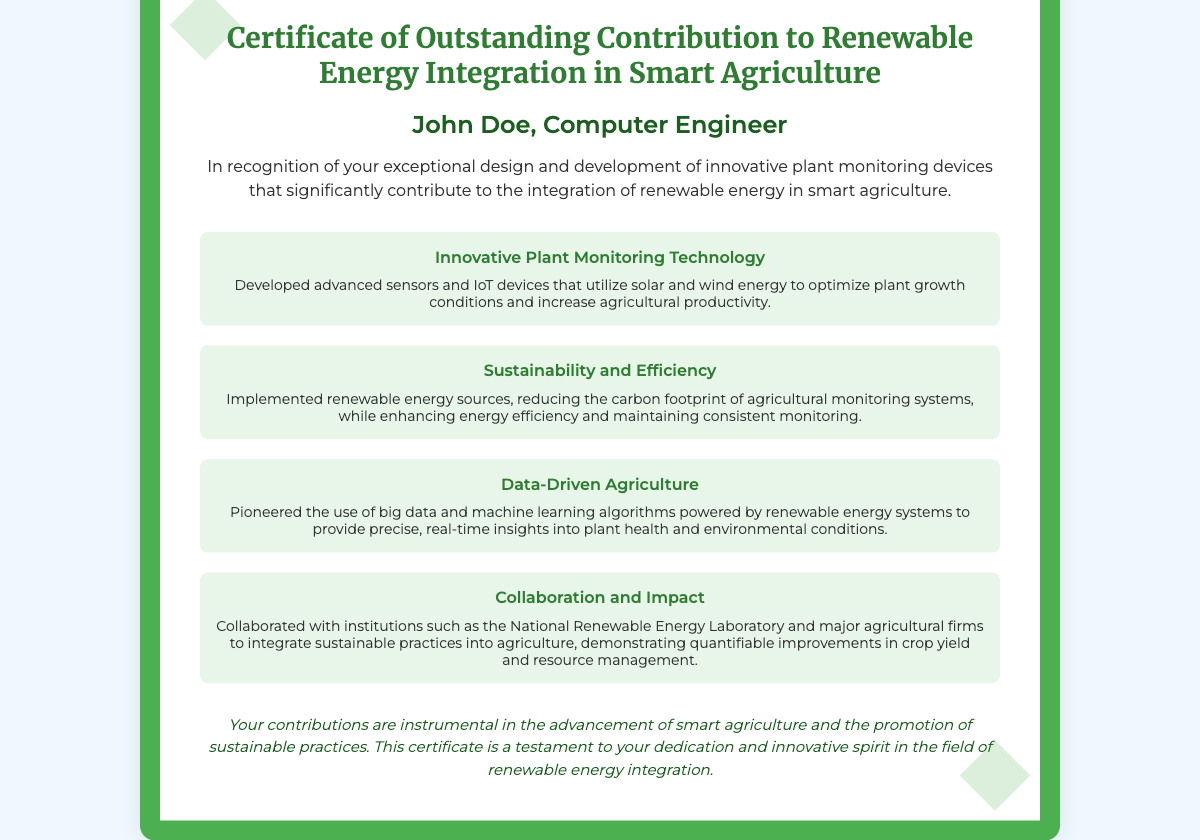What is the title of the certificate? The title of the certificate is prominently displayed at the top of the document.
Answer: Certificate of Outstanding Contribution to Renewable Energy Integration in Smart Agriculture Who is the recipient of the certificate? The recipient's name is stated below the title of the certificate.
Answer: John Doe, Computer Engineer What is one key area of contribution mentioned in the certificate? Several areas of contribution are highlighted, each with a title.
Answer: Innovative Plant Monitoring Technology How did John Doe contribute to sustainability? The document describes how he implemented renewable energy sources affecting agricultural systems.
Answer: Reducing the carbon footprint What technology did John Doe pioneer in agriculture? The certificate mentions the use of specific technologies he developed in agriculture.
Answer: Big data and machine learning algorithms Which institutions did John Doe collaborate with? The document provides details about organizations he worked with.
Answer: National Renewable Energy Laboratory What is the purpose of this certificate? The main intent of the certificate is stated in the introductory section.
Answer: Recognition of exceptional design and development What is the color theme of the certificate? The design elements indicate the dominant colors used in the certificate.
Answer: Green and white 